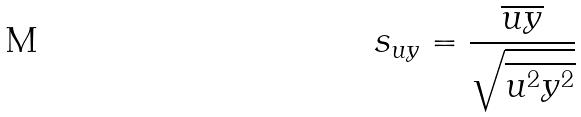Convert formula to latex. <formula><loc_0><loc_0><loc_500><loc_500>s _ { u y } = \frac { \overline { u y } } { \sqrt { \overline { u ^ { 2 } } \overline { y ^ { 2 } } } }</formula> 